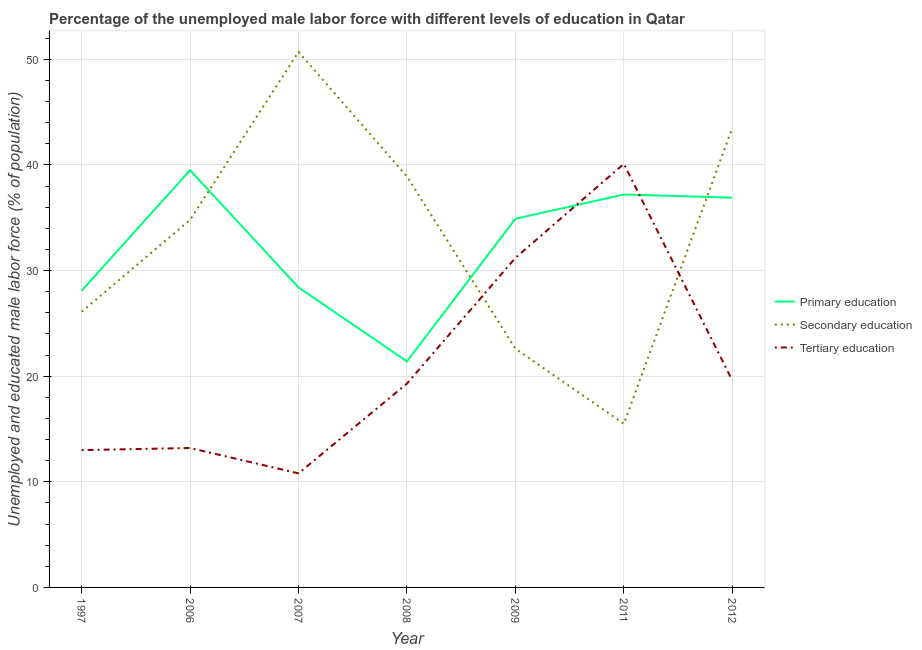Does the line corresponding to percentage of male labor force who received secondary education intersect with the line corresponding to percentage of male labor force who received primary education?
Your answer should be compact. Yes. What is the percentage of male labor force who received primary education in 2012?
Your answer should be very brief. 36.9. Across all years, what is the maximum percentage of male labor force who received tertiary education?
Provide a succinct answer. 40.1. Across all years, what is the minimum percentage of male labor force who received tertiary education?
Provide a short and direct response. 10.8. What is the total percentage of male labor force who received secondary education in the graph?
Make the answer very short. 232.1. What is the difference between the percentage of male labor force who received secondary education in 2008 and that in 2009?
Keep it short and to the point. 16.3. What is the difference between the percentage of male labor force who received tertiary education in 2007 and the percentage of male labor force who received primary education in 2009?
Make the answer very short. -24.1. What is the average percentage of male labor force who received primary education per year?
Your answer should be compact. 32.34. In the year 2008, what is the difference between the percentage of male labor force who received primary education and percentage of male labor force who received secondary education?
Give a very brief answer. -17.5. In how many years, is the percentage of male labor force who received secondary education greater than 50 %?
Give a very brief answer. 1. What is the ratio of the percentage of male labor force who received tertiary education in 2008 to that in 2012?
Your answer should be very brief. 0.98. Is the percentage of male labor force who received tertiary education in 2011 less than that in 2012?
Provide a short and direct response. No. Is the difference between the percentage of male labor force who received secondary education in 1997 and 2011 greater than the difference between the percentage of male labor force who received primary education in 1997 and 2011?
Give a very brief answer. Yes. What is the difference between the highest and the second highest percentage of male labor force who received tertiary education?
Provide a succinct answer. 8.9. What is the difference between the highest and the lowest percentage of male labor force who received secondary education?
Provide a short and direct response. 35.2. Does the percentage of male labor force who received secondary education monotonically increase over the years?
Give a very brief answer. No. Is the percentage of male labor force who received secondary education strictly greater than the percentage of male labor force who received primary education over the years?
Your response must be concise. No. How many years are there in the graph?
Offer a very short reply. 7. What is the difference between two consecutive major ticks on the Y-axis?
Ensure brevity in your answer.  10. Does the graph contain any zero values?
Give a very brief answer. No. Does the graph contain grids?
Offer a very short reply. Yes. Where does the legend appear in the graph?
Make the answer very short. Center right. How are the legend labels stacked?
Provide a short and direct response. Vertical. What is the title of the graph?
Your response must be concise. Percentage of the unemployed male labor force with different levels of education in Qatar. What is the label or title of the Y-axis?
Keep it short and to the point. Unemployed and educated male labor force (% of population). What is the Unemployed and educated male labor force (% of population) in Primary education in 1997?
Provide a short and direct response. 28.1. What is the Unemployed and educated male labor force (% of population) of Secondary education in 1997?
Provide a short and direct response. 26.1. What is the Unemployed and educated male labor force (% of population) of Tertiary education in 1997?
Provide a succinct answer. 13. What is the Unemployed and educated male labor force (% of population) in Primary education in 2006?
Provide a short and direct response. 39.5. What is the Unemployed and educated male labor force (% of population) in Secondary education in 2006?
Provide a succinct answer. 34.8. What is the Unemployed and educated male labor force (% of population) in Tertiary education in 2006?
Your answer should be very brief. 13.2. What is the Unemployed and educated male labor force (% of population) of Primary education in 2007?
Offer a very short reply. 28.4. What is the Unemployed and educated male labor force (% of population) of Secondary education in 2007?
Your response must be concise. 50.7. What is the Unemployed and educated male labor force (% of population) in Tertiary education in 2007?
Your answer should be compact. 10.8. What is the Unemployed and educated male labor force (% of population) in Primary education in 2008?
Give a very brief answer. 21.4. What is the Unemployed and educated male labor force (% of population) of Secondary education in 2008?
Your answer should be very brief. 38.9. What is the Unemployed and educated male labor force (% of population) of Tertiary education in 2008?
Keep it short and to the point. 19.3. What is the Unemployed and educated male labor force (% of population) of Primary education in 2009?
Keep it short and to the point. 34.9. What is the Unemployed and educated male labor force (% of population) of Secondary education in 2009?
Offer a terse response. 22.6. What is the Unemployed and educated male labor force (% of population) of Tertiary education in 2009?
Provide a succinct answer. 31.2. What is the Unemployed and educated male labor force (% of population) of Primary education in 2011?
Ensure brevity in your answer.  37.2. What is the Unemployed and educated male labor force (% of population) in Secondary education in 2011?
Make the answer very short. 15.5. What is the Unemployed and educated male labor force (% of population) of Tertiary education in 2011?
Give a very brief answer. 40.1. What is the Unemployed and educated male labor force (% of population) of Primary education in 2012?
Offer a very short reply. 36.9. What is the Unemployed and educated male labor force (% of population) of Secondary education in 2012?
Offer a terse response. 43.5. What is the Unemployed and educated male labor force (% of population) in Tertiary education in 2012?
Provide a short and direct response. 19.6. Across all years, what is the maximum Unemployed and educated male labor force (% of population) in Primary education?
Provide a succinct answer. 39.5. Across all years, what is the maximum Unemployed and educated male labor force (% of population) of Secondary education?
Provide a short and direct response. 50.7. Across all years, what is the maximum Unemployed and educated male labor force (% of population) of Tertiary education?
Offer a very short reply. 40.1. Across all years, what is the minimum Unemployed and educated male labor force (% of population) in Primary education?
Offer a very short reply. 21.4. Across all years, what is the minimum Unemployed and educated male labor force (% of population) in Secondary education?
Your answer should be compact. 15.5. Across all years, what is the minimum Unemployed and educated male labor force (% of population) of Tertiary education?
Provide a succinct answer. 10.8. What is the total Unemployed and educated male labor force (% of population) of Primary education in the graph?
Your answer should be very brief. 226.4. What is the total Unemployed and educated male labor force (% of population) of Secondary education in the graph?
Provide a succinct answer. 232.1. What is the total Unemployed and educated male labor force (% of population) of Tertiary education in the graph?
Your answer should be very brief. 147.2. What is the difference between the Unemployed and educated male labor force (% of population) in Secondary education in 1997 and that in 2006?
Make the answer very short. -8.7. What is the difference between the Unemployed and educated male labor force (% of population) in Tertiary education in 1997 and that in 2006?
Your answer should be very brief. -0.2. What is the difference between the Unemployed and educated male labor force (% of population) in Secondary education in 1997 and that in 2007?
Make the answer very short. -24.6. What is the difference between the Unemployed and educated male labor force (% of population) in Secondary education in 1997 and that in 2008?
Your answer should be very brief. -12.8. What is the difference between the Unemployed and educated male labor force (% of population) in Tertiary education in 1997 and that in 2008?
Your answer should be very brief. -6.3. What is the difference between the Unemployed and educated male labor force (% of population) of Primary education in 1997 and that in 2009?
Offer a terse response. -6.8. What is the difference between the Unemployed and educated male labor force (% of population) of Tertiary education in 1997 and that in 2009?
Your answer should be compact. -18.2. What is the difference between the Unemployed and educated male labor force (% of population) in Tertiary education in 1997 and that in 2011?
Provide a short and direct response. -27.1. What is the difference between the Unemployed and educated male labor force (% of population) in Primary education in 1997 and that in 2012?
Keep it short and to the point. -8.8. What is the difference between the Unemployed and educated male labor force (% of population) in Secondary education in 1997 and that in 2012?
Give a very brief answer. -17.4. What is the difference between the Unemployed and educated male labor force (% of population) in Tertiary education in 1997 and that in 2012?
Ensure brevity in your answer.  -6.6. What is the difference between the Unemployed and educated male labor force (% of population) in Secondary education in 2006 and that in 2007?
Your answer should be compact. -15.9. What is the difference between the Unemployed and educated male labor force (% of population) of Tertiary education in 2006 and that in 2007?
Provide a succinct answer. 2.4. What is the difference between the Unemployed and educated male labor force (% of population) of Secondary education in 2006 and that in 2008?
Provide a succinct answer. -4.1. What is the difference between the Unemployed and educated male labor force (% of population) in Primary education in 2006 and that in 2009?
Your answer should be very brief. 4.6. What is the difference between the Unemployed and educated male labor force (% of population) in Secondary education in 2006 and that in 2009?
Your response must be concise. 12.2. What is the difference between the Unemployed and educated male labor force (% of population) in Tertiary education in 2006 and that in 2009?
Offer a very short reply. -18. What is the difference between the Unemployed and educated male labor force (% of population) in Secondary education in 2006 and that in 2011?
Provide a succinct answer. 19.3. What is the difference between the Unemployed and educated male labor force (% of population) of Tertiary education in 2006 and that in 2011?
Make the answer very short. -26.9. What is the difference between the Unemployed and educated male labor force (% of population) of Primary education in 2006 and that in 2012?
Keep it short and to the point. 2.6. What is the difference between the Unemployed and educated male labor force (% of population) of Secondary education in 2006 and that in 2012?
Offer a terse response. -8.7. What is the difference between the Unemployed and educated male labor force (% of population) in Tertiary education in 2006 and that in 2012?
Provide a succinct answer. -6.4. What is the difference between the Unemployed and educated male labor force (% of population) in Primary education in 2007 and that in 2009?
Provide a short and direct response. -6.5. What is the difference between the Unemployed and educated male labor force (% of population) of Secondary education in 2007 and that in 2009?
Give a very brief answer. 28.1. What is the difference between the Unemployed and educated male labor force (% of population) of Tertiary education in 2007 and that in 2009?
Offer a terse response. -20.4. What is the difference between the Unemployed and educated male labor force (% of population) in Secondary education in 2007 and that in 2011?
Your answer should be very brief. 35.2. What is the difference between the Unemployed and educated male labor force (% of population) in Tertiary education in 2007 and that in 2011?
Offer a terse response. -29.3. What is the difference between the Unemployed and educated male labor force (% of population) in Primary education in 2007 and that in 2012?
Offer a terse response. -8.5. What is the difference between the Unemployed and educated male labor force (% of population) of Secondary education in 2007 and that in 2012?
Your answer should be compact. 7.2. What is the difference between the Unemployed and educated male labor force (% of population) in Primary education in 2008 and that in 2009?
Ensure brevity in your answer.  -13.5. What is the difference between the Unemployed and educated male labor force (% of population) in Primary education in 2008 and that in 2011?
Give a very brief answer. -15.8. What is the difference between the Unemployed and educated male labor force (% of population) in Secondary education in 2008 and that in 2011?
Give a very brief answer. 23.4. What is the difference between the Unemployed and educated male labor force (% of population) in Tertiary education in 2008 and that in 2011?
Make the answer very short. -20.8. What is the difference between the Unemployed and educated male labor force (% of population) in Primary education in 2008 and that in 2012?
Provide a short and direct response. -15.5. What is the difference between the Unemployed and educated male labor force (% of population) of Tertiary education in 2009 and that in 2011?
Give a very brief answer. -8.9. What is the difference between the Unemployed and educated male labor force (% of population) of Primary education in 2009 and that in 2012?
Your answer should be very brief. -2. What is the difference between the Unemployed and educated male labor force (% of population) of Secondary education in 2009 and that in 2012?
Give a very brief answer. -20.9. What is the difference between the Unemployed and educated male labor force (% of population) in Tertiary education in 2009 and that in 2012?
Ensure brevity in your answer.  11.6. What is the difference between the Unemployed and educated male labor force (% of population) in Primary education in 2011 and that in 2012?
Your answer should be very brief. 0.3. What is the difference between the Unemployed and educated male labor force (% of population) in Secondary education in 2011 and that in 2012?
Your answer should be compact. -28. What is the difference between the Unemployed and educated male labor force (% of population) of Primary education in 1997 and the Unemployed and educated male labor force (% of population) of Tertiary education in 2006?
Your response must be concise. 14.9. What is the difference between the Unemployed and educated male labor force (% of population) in Primary education in 1997 and the Unemployed and educated male labor force (% of population) in Secondary education in 2007?
Offer a very short reply. -22.6. What is the difference between the Unemployed and educated male labor force (% of population) in Primary education in 1997 and the Unemployed and educated male labor force (% of population) in Tertiary education in 2007?
Your answer should be very brief. 17.3. What is the difference between the Unemployed and educated male labor force (% of population) of Secondary education in 1997 and the Unemployed and educated male labor force (% of population) of Tertiary education in 2007?
Your answer should be very brief. 15.3. What is the difference between the Unemployed and educated male labor force (% of population) in Primary education in 1997 and the Unemployed and educated male labor force (% of population) in Secondary education in 2008?
Give a very brief answer. -10.8. What is the difference between the Unemployed and educated male labor force (% of population) of Secondary education in 1997 and the Unemployed and educated male labor force (% of population) of Tertiary education in 2008?
Ensure brevity in your answer.  6.8. What is the difference between the Unemployed and educated male labor force (% of population) of Primary education in 1997 and the Unemployed and educated male labor force (% of population) of Secondary education in 2009?
Provide a succinct answer. 5.5. What is the difference between the Unemployed and educated male labor force (% of population) in Primary education in 1997 and the Unemployed and educated male labor force (% of population) in Tertiary education in 2009?
Offer a very short reply. -3.1. What is the difference between the Unemployed and educated male labor force (% of population) of Secondary education in 1997 and the Unemployed and educated male labor force (% of population) of Tertiary education in 2009?
Offer a terse response. -5.1. What is the difference between the Unemployed and educated male labor force (% of population) in Primary education in 1997 and the Unemployed and educated male labor force (% of population) in Tertiary education in 2011?
Your answer should be very brief. -12. What is the difference between the Unemployed and educated male labor force (% of population) in Secondary education in 1997 and the Unemployed and educated male labor force (% of population) in Tertiary education in 2011?
Your answer should be very brief. -14. What is the difference between the Unemployed and educated male labor force (% of population) in Primary education in 1997 and the Unemployed and educated male labor force (% of population) in Secondary education in 2012?
Provide a succinct answer. -15.4. What is the difference between the Unemployed and educated male labor force (% of population) of Primary education in 1997 and the Unemployed and educated male labor force (% of population) of Tertiary education in 2012?
Offer a very short reply. 8.5. What is the difference between the Unemployed and educated male labor force (% of population) in Secondary education in 1997 and the Unemployed and educated male labor force (% of population) in Tertiary education in 2012?
Give a very brief answer. 6.5. What is the difference between the Unemployed and educated male labor force (% of population) in Primary education in 2006 and the Unemployed and educated male labor force (% of population) in Tertiary education in 2007?
Give a very brief answer. 28.7. What is the difference between the Unemployed and educated male labor force (% of population) in Secondary education in 2006 and the Unemployed and educated male labor force (% of population) in Tertiary education in 2007?
Make the answer very short. 24. What is the difference between the Unemployed and educated male labor force (% of population) in Primary education in 2006 and the Unemployed and educated male labor force (% of population) in Tertiary education in 2008?
Offer a very short reply. 20.2. What is the difference between the Unemployed and educated male labor force (% of population) in Primary education in 2006 and the Unemployed and educated male labor force (% of population) in Secondary education in 2011?
Give a very brief answer. 24. What is the difference between the Unemployed and educated male labor force (% of population) in Primary education in 2006 and the Unemployed and educated male labor force (% of population) in Tertiary education in 2012?
Offer a terse response. 19.9. What is the difference between the Unemployed and educated male labor force (% of population) in Secondary education in 2006 and the Unemployed and educated male labor force (% of population) in Tertiary education in 2012?
Give a very brief answer. 15.2. What is the difference between the Unemployed and educated male labor force (% of population) in Primary education in 2007 and the Unemployed and educated male labor force (% of population) in Tertiary education in 2008?
Ensure brevity in your answer.  9.1. What is the difference between the Unemployed and educated male labor force (% of population) in Secondary education in 2007 and the Unemployed and educated male labor force (% of population) in Tertiary education in 2008?
Make the answer very short. 31.4. What is the difference between the Unemployed and educated male labor force (% of population) of Primary education in 2007 and the Unemployed and educated male labor force (% of population) of Secondary education in 2009?
Keep it short and to the point. 5.8. What is the difference between the Unemployed and educated male labor force (% of population) of Secondary education in 2007 and the Unemployed and educated male labor force (% of population) of Tertiary education in 2009?
Provide a short and direct response. 19.5. What is the difference between the Unemployed and educated male labor force (% of population) in Primary education in 2007 and the Unemployed and educated male labor force (% of population) in Tertiary education in 2011?
Provide a short and direct response. -11.7. What is the difference between the Unemployed and educated male labor force (% of population) of Primary education in 2007 and the Unemployed and educated male labor force (% of population) of Secondary education in 2012?
Make the answer very short. -15.1. What is the difference between the Unemployed and educated male labor force (% of population) of Secondary education in 2007 and the Unemployed and educated male labor force (% of population) of Tertiary education in 2012?
Ensure brevity in your answer.  31.1. What is the difference between the Unemployed and educated male labor force (% of population) in Primary education in 2008 and the Unemployed and educated male labor force (% of population) in Secondary education in 2009?
Provide a succinct answer. -1.2. What is the difference between the Unemployed and educated male labor force (% of population) in Primary education in 2008 and the Unemployed and educated male labor force (% of population) in Secondary education in 2011?
Your answer should be very brief. 5.9. What is the difference between the Unemployed and educated male labor force (% of population) of Primary education in 2008 and the Unemployed and educated male labor force (% of population) of Tertiary education in 2011?
Keep it short and to the point. -18.7. What is the difference between the Unemployed and educated male labor force (% of population) of Primary education in 2008 and the Unemployed and educated male labor force (% of population) of Secondary education in 2012?
Keep it short and to the point. -22.1. What is the difference between the Unemployed and educated male labor force (% of population) in Secondary education in 2008 and the Unemployed and educated male labor force (% of population) in Tertiary education in 2012?
Keep it short and to the point. 19.3. What is the difference between the Unemployed and educated male labor force (% of population) of Primary education in 2009 and the Unemployed and educated male labor force (% of population) of Secondary education in 2011?
Ensure brevity in your answer.  19.4. What is the difference between the Unemployed and educated male labor force (% of population) in Secondary education in 2009 and the Unemployed and educated male labor force (% of population) in Tertiary education in 2011?
Make the answer very short. -17.5. What is the difference between the Unemployed and educated male labor force (% of population) of Primary education in 2009 and the Unemployed and educated male labor force (% of population) of Secondary education in 2012?
Offer a very short reply. -8.6. What is the difference between the Unemployed and educated male labor force (% of population) of Primary education in 2011 and the Unemployed and educated male labor force (% of population) of Tertiary education in 2012?
Ensure brevity in your answer.  17.6. What is the difference between the Unemployed and educated male labor force (% of population) of Secondary education in 2011 and the Unemployed and educated male labor force (% of population) of Tertiary education in 2012?
Provide a succinct answer. -4.1. What is the average Unemployed and educated male labor force (% of population) of Primary education per year?
Ensure brevity in your answer.  32.34. What is the average Unemployed and educated male labor force (% of population) in Secondary education per year?
Offer a terse response. 33.16. What is the average Unemployed and educated male labor force (% of population) in Tertiary education per year?
Your response must be concise. 21.03. In the year 1997, what is the difference between the Unemployed and educated male labor force (% of population) of Primary education and Unemployed and educated male labor force (% of population) of Tertiary education?
Provide a succinct answer. 15.1. In the year 2006, what is the difference between the Unemployed and educated male labor force (% of population) in Primary education and Unemployed and educated male labor force (% of population) in Secondary education?
Provide a succinct answer. 4.7. In the year 2006, what is the difference between the Unemployed and educated male labor force (% of population) in Primary education and Unemployed and educated male labor force (% of population) in Tertiary education?
Make the answer very short. 26.3. In the year 2006, what is the difference between the Unemployed and educated male labor force (% of population) in Secondary education and Unemployed and educated male labor force (% of population) in Tertiary education?
Your answer should be compact. 21.6. In the year 2007, what is the difference between the Unemployed and educated male labor force (% of population) in Primary education and Unemployed and educated male labor force (% of population) in Secondary education?
Provide a short and direct response. -22.3. In the year 2007, what is the difference between the Unemployed and educated male labor force (% of population) in Primary education and Unemployed and educated male labor force (% of population) in Tertiary education?
Your response must be concise. 17.6. In the year 2007, what is the difference between the Unemployed and educated male labor force (% of population) in Secondary education and Unemployed and educated male labor force (% of population) in Tertiary education?
Ensure brevity in your answer.  39.9. In the year 2008, what is the difference between the Unemployed and educated male labor force (% of population) in Primary education and Unemployed and educated male labor force (% of population) in Secondary education?
Provide a succinct answer. -17.5. In the year 2008, what is the difference between the Unemployed and educated male labor force (% of population) in Secondary education and Unemployed and educated male labor force (% of population) in Tertiary education?
Your answer should be very brief. 19.6. In the year 2009, what is the difference between the Unemployed and educated male labor force (% of population) in Primary education and Unemployed and educated male labor force (% of population) in Secondary education?
Provide a succinct answer. 12.3. In the year 2009, what is the difference between the Unemployed and educated male labor force (% of population) of Secondary education and Unemployed and educated male labor force (% of population) of Tertiary education?
Your answer should be compact. -8.6. In the year 2011, what is the difference between the Unemployed and educated male labor force (% of population) in Primary education and Unemployed and educated male labor force (% of population) in Secondary education?
Keep it short and to the point. 21.7. In the year 2011, what is the difference between the Unemployed and educated male labor force (% of population) in Secondary education and Unemployed and educated male labor force (% of population) in Tertiary education?
Your response must be concise. -24.6. In the year 2012, what is the difference between the Unemployed and educated male labor force (% of population) of Primary education and Unemployed and educated male labor force (% of population) of Tertiary education?
Give a very brief answer. 17.3. In the year 2012, what is the difference between the Unemployed and educated male labor force (% of population) of Secondary education and Unemployed and educated male labor force (% of population) of Tertiary education?
Give a very brief answer. 23.9. What is the ratio of the Unemployed and educated male labor force (% of population) in Primary education in 1997 to that in 2006?
Make the answer very short. 0.71. What is the ratio of the Unemployed and educated male labor force (% of population) of Secondary education in 1997 to that in 2007?
Offer a very short reply. 0.51. What is the ratio of the Unemployed and educated male labor force (% of population) in Tertiary education in 1997 to that in 2007?
Your answer should be very brief. 1.2. What is the ratio of the Unemployed and educated male labor force (% of population) of Primary education in 1997 to that in 2008?
Offer a terse response. 1.31. What is the ratio of the Unemployed and educated male labor force (% of population) in Secondary education in 1997 to that in 2008?
Make the answer very short. 0.67. What is the ratio of the Unemployed and educated male labor force (% of population) in Tertiary education in 1997 to that in 2008?
Provide a succinct answer. 0.67. What is the ratio of the Unemployed and educated male labor force (% of population) of Primary education in 1997 to that in 2009?
Your response must be concise. 0.81. What is the ratio of the Unemployed and educated male labor force (% of population) in Secondary education in 1997 to that in 2009?
Offer a very short reply. 1.15. What is the ratio of the Unemployed and educated male labor force (% of population) in Tertiary education in 1997 to that in 2009?
Keep it short and to the point. 0.42. What is the ratio of the Unemployed and educated male labor force (% of population) in Primary education in 1997 to that in 2011?
Offer a terse response. 0.76. What is the ratio of the Unemployed and educated male labor force (% of population) of Secondary education in 1997 to that in 2011?
Ensure brevity in your answer.  1.68. What is the ratio of the Unemployed and educated male labor force (% of population) in Tertiary education in 1997 to that in 2011?
Your answer should be compact. 0.32. What is the ratio of the Unemployed and educated male labor force (% of population) of Primary education in 1997 to that in 2012?
Provide a short and direct response. 0.76. What is the ratio of the Unemployed and educated male labor force (% of population) in Secondary education in 1997 to that in 2012?
Your answer should be very brief. 0.6. What is the ratio of the Unemployed and educated male labor force (% of population) in Tertiary education in 1997 to that in 2012?
Make the answer very short. 0.66. What is the ratio of the Unemployed and educated male labor force (% of population) of Primary education in 2006 to that in 2007?
Your response must be concise. 1.39. What is the ratio of the Unemployed and educated male labor force (% of population) of Secondary education in 2006 to that in 2007?
Make the answer very short. 0.69. What is the ratio of the Unemployed and educated male labor force (% of population) of Tertiary education in 2006 to that in 2007?
Provide a succinct answer. 1.22. What is the ratio of the Unemployed and educated male labor force (% of population) of Primary education in 2006 to that in 2008?
Make the answer very short. 1.85. What is the ratio of the Unemployed and educated male labor force (% of population) of Secondary education in 2006 to that in 2008?
Make the answer very short. 0.89. What is the ratio of the Unemployed and educated male labor force (% of population) in Tertiary education in 2006 to that in 2008?
Your answer should be compact. 0.68. What is the ratio of the Unemployed and educated male labor force (% of population) in Primary education in 2006 to that in 2009?
Your answer should be compact. 1.13. What is the ratio of the Unemployed and educated male labor force (% of population) in Secondary education in 2006 to that in 2009?
Keep it short and to the point. 1.54. What is the ratio of the Unemployed and educated male labor force (% of population) in Tertiary education in 2006 to that in 2009?
Give a very brief answer. 0.42. What is the ratio of the Unemployed and educated male labor force (% of population) of Primary education in 2006 to that in 2011?
Make the answer very short. 1.06. What is the ratio of the Unemployed and educated male labor force (% of population) in Secondary education in 2006 to that in 2011?
Provide a succinct answer. 2.25. What is the ratio of the Unemployed and educated male labor force (% of population) of Tertiary education in 2006 to that in 2011?
Ensure brevity in your answer.  0.33. What is the ratio of the Unemployed and educated male labor force (% of population) of Primary education in 2006 to that in 2012?
Your answer should be very brief. 1.07. What is the ratio of the Unemployed and educated male labor force (% of population) in Tertiary education in 2006 to that in 2012?
Your response must be concise. 0.67. What is the ratio of the Unemployed and educated male labor force (% of population) in Primary education in 2007 to that in 2008?
Your answer should be very brief. 1.33. What is the ratio of the Unemployed and educated male labor force (% of population) of Secondary education in 2007 to that in 2008?
Give a very brief answer. 1.3. What is the ratio of the Unemployed and educated male labor force (% of population) of Tertiary education in 2007 to that in 2008?
Provide a short and direct response. 0.56. What is the ratio of the Unemployed and educated male labor force (% of population) of Primary education in 2007 to that in 2009?
Your answer should be very brief. 0.81. What is the ratio of the Unemployed and educated male labor force (% of population) in Secondary education in 2007 to that in 2009?
Ensure brevity in your answer.  2.24. What is the ratio of the Unemployed and educated male labor force (% of population) of Tertiary education in 2007 to that in 2009?
Offer a very short reply. 0.35. What is the ratio of the Unemployed and educated male labor force (% of population) in Primary education in 2007 to that in 2011?
Your answer should be compact. 0.76. What is the ratio of the Unemployed and educated male labor force (% of population) of Secondary education in 2007 to that in 2011?
Offer a very short reply. 3.27. What is the ratio of the Unemployed and educated male labor force (% of population) of Tertiary education in 2007 to that in 2011?
Offer a very short reply. 0.27. What is the ratio of the Unemployed and educated male labor force (% of population) of Primary education in 2007 to that in 2012?
Give a very brief answer. 0.77. What is the ratio of the Unemployed and educated male labor force (% of population) in Secondary education in 2007 to that in 2012?
Ensure brevity in your answer.  1.17. What is the ratio of the Unemployed and educated male labor force (% of population) of Tertiary education in 2007 to that in 2012?
Your answer should be very brief. 0.55. What is the ratio of the Unemployed and educated male labor force (% of population) of Primary education in 2008 to that in 2009?
Ensure brevity in your answer.  0.61. What is the ratio of the Unemployed and educated male labor force (% of population) of Secondary education in 2008 to that in 2009?
Your response must be concise. 1.72. What is the ratio of the Unemployed and educated male labor force (% of population) in Tertiary education in 2008 to that in 2009?
Offer a terse response. 0.62. What is the ratio of the Unemployed and educated male labor force (% of population) in Primary education in 2008 to that in 2011?
Provide a short and direct response. 0.58. What is the ratio of the Unemployed and educated male labor force (% of population) of Secondary education in 2008 to that in 2011?
Give a very brief answer. 2.51. What is the ratio of the Unemployed and educated male labor force (% of population) in Tertiary education in 2008 to that in 2011?
Give a very brief answer. 0.48. What is the ratio of the Unemployed and educated male labor force (% of population) in Primary education in 2008 to that in 2012?
Provide a succinct answer. 0.58. What is the ratio of the Unemployed and educated male labor force (% of population) of Secondary education in 2008 to that in 2012?
Your answer should be very brief. 0.89. What is the ratio of the Unemployed and educated male labor force (% of population) of Tertiary education in 2008 to that in 2012?
Make the answer very short. 0.98. What is the ratio of the Unemployed and educated male labor force (% of population) in Primary education in 2009 to that in 2011?
Your response must be concise. 0.94. What is the ratio of the Unemployed and educated male labor force (% of population) in Secondary education in 2009 to that in 2011?
Provide a succinct answer. 1.46. What is the ratio of the Unemployed and educated male labor force (% of population) of Tertiary education in 2009 to that in 2011?
Your answer should be very brief. 0.78. What is the ratio of the Unemployed and educated male labor force (% of population) in Primary education in 2009 to that in 2012?
Ensure brevity in your answer.  0.95. What is the ratio of the Unemployed and educated male labor force (% of population) of Secondary education in 2009 to that in 2012?
Your answer should be compact. 0.52. What is the ratio of the Unemployed and educated male labor force (% of population) in Tertiary education in 2009 to that in 2012?
Ensure brevity in your answer.  1.59. What is the ratio of the Unemployed and educated male labor force (% of population) of Secondary education in 2011 to that in 2012?
Offer a terse response. 0.36. What is the ratio of the Unemployed and educated male labor force (% of population) in Tertiary education in 2011 to that in 2012?
Provide a short and direct response. 2.05. What is the difference between the highest and the second highest Unemployed and educated male labor force (% of population) in Primary education?
Offer a terse response. 2.3. What is the difference between the highest and the lowest Unemployed and educated male labor force (% of population) in Primary education?
Provide a succinct answer. 18.1. What is the difference between the highest and the lowest Unemployed and educated male labor force (% of population) of Secondary education?
Your answer should be compact. 35.2. What is the difference between the highest and the lowest Unemployed and educated male labor force (% of population) in Tertiary education?
Ensure brevity in your answer.  29.3. 